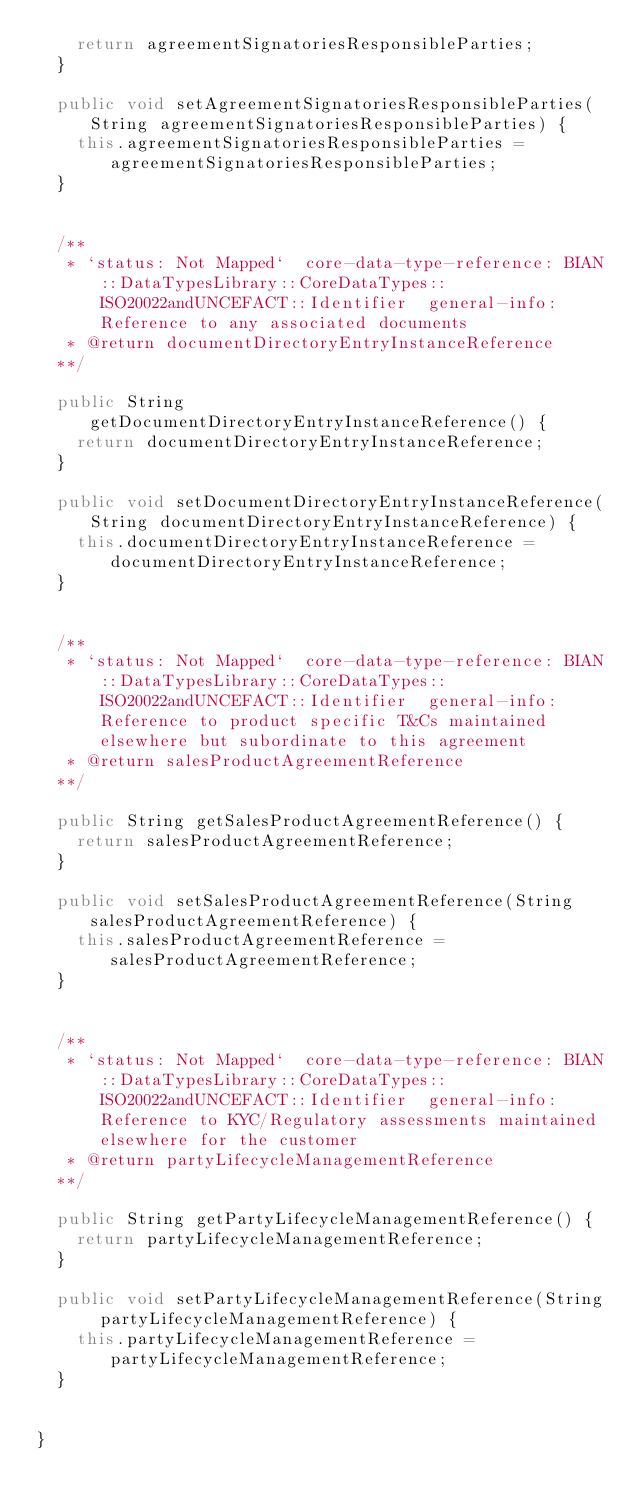Convert code to text. <code><loc_0><loc_0><loc_500><loc_500><_Java_>    return agreementSignatoriesResponsibleParties;
  }

  public void setAgreementSignatoriesResponsibleParties(String agreementSignatoriesResponsibleParties) {
    this.agreementSignatoriesResponsibleParties = agreementSignatoriesResponsibleParties;
  }


  /**
   * `status: Not Mapped`  core-data-type-reference: BIAN::DataTypesLibrary::CoreDataTypes::ISO20022andUNCEFACT::Identifier  general-info: Reference to any associated documents 
   * @return documentDirectoryEntryInstanceReference
  **/

  public String getDocumentDirectoryEntryInstanceReference() {
    return documentDirectoryEntryInstanceReference;
  }

  public void setDocumentDirectoryEntryInstanceReference(String documentDirectoryEntryInstanceReference) {
    this.documentDirectoryEntryInstanceReference = documentDirectoryEntryInstanceReference;
  }


  /**
   * `status: Not Mapped`  core-data-type-reference: BIAN::DataTypesLibrary::CoreDataTypes::ISO20022andUNCEFACT::Identifier  general-info: Reference to product specific T&Cs maintained elsewhere but subordinate to this agreement 
   * @return salesProductAgreementReference
  **/

  public String getSalesProductAgreementReference() {
    return salesProductAgreementReference;
  }

  public void setSalesProductAgreementReference(String salesProductAgreementReference) {
    this.salesProductAgreementReference = salesProductAgreementReference;
  }


  /**
   * `status: Not Mapped`  core-data-type-reference: BIAN::DataTypesLibrary::CoreDataTypes::ISO20022andUNCEFACT::Identifier  general-info: Reference to KYC/Regulatory assessments maintained elsewhere for the customer 
   * @return partyLifecycleManagementReference
  **/

  public String getPartyLifecycleManagementReference() {
    return partyLifecycleManagementReference;
  }

  public void setPartyLifecycleManagementReference(String partyLifecycleManagementReference) {
    this.partyLifecycleManagementReference = partyLifecycleManagementReference;
  }


}

</code> 